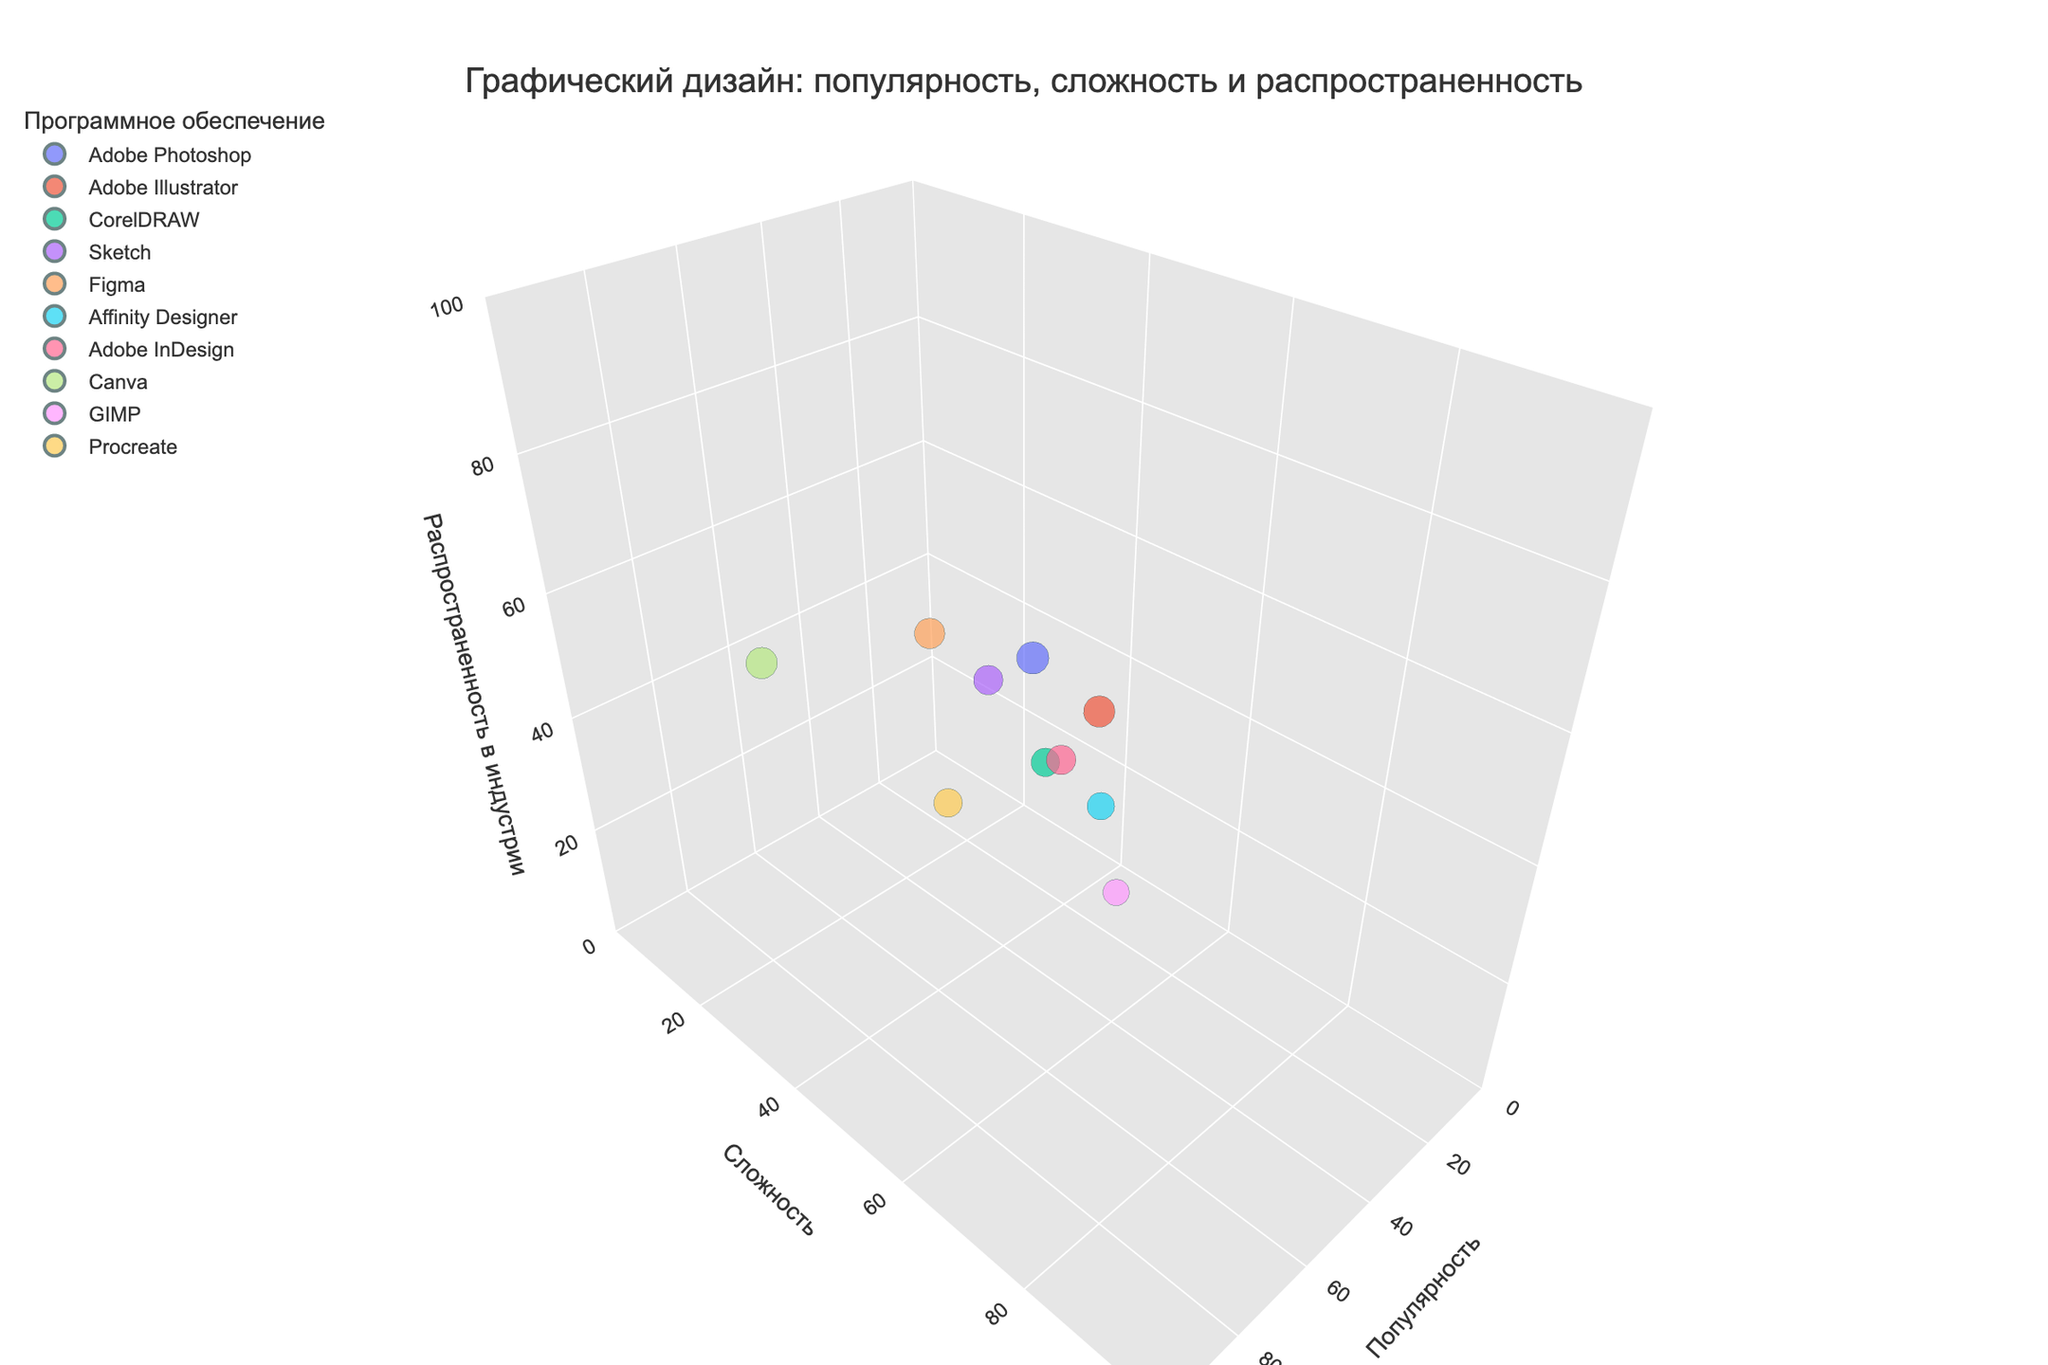How many software tools have a popularity higher than 80? By looking at the "Популярность" axis, identify the tools with a popularity value greater than 80. These are Adobe Photoshop, Adobe Illustrator, Canva, and Figma.
Answer: 4 Which software has the highest complexity and what is its value? Observe the "Сложность" axis and find the software with the maximal value. GIMP has the highest complexity with a value of 70.
Answer: GIMP, 70 Which software tools have an industry adoption rate equal to or higher than 70? Check the "Распространенность в индустрии" axis for values equal to or exceeding 70. Adobe Photoshop, Adobe Illustrator, Sketch, and Figma meet this criterion.
Answer: Adobe Photoshop, Adobe Illustrator, Sketch, Figma What is the combined popularity score of CorelDRAW, Sketch, and Procreate? Add the popularity scores of CorelDRAW (70), Sketch (75), and Procreate (70) together: 70 + 75 + 70.
Answer: 215 Is there any software that has both a complexity and industry adoption rate lower than 60? Examine the "Сложность" and "Распространенность в индустрии" axes. Procreate has a complexity of 50 and an industry adoption rate of 45, both below 60.
Answer: Yes, Procreate Compare Adobe InDesign and Affinity Designer in terms of industry adoption. Which one is higher and by how much? Look at their positions on the "Распространенность в индустрии" axis. Adobe InDesign has a rate of 65 and Affinity Designer has 55, so InDesign is higher by 10.
Answer: Adobe InDesign by 10 Which software tool has the largest bubble size, and what does it represent? The largest bubble-size corresponds to the highest popularity score. Adobe Photoshop, which has a popularity score of 90, has the largest bubble.
Answer: Adobe Photoshop, 90 What is the average complexity of Adobe Photoshop and Adobe Illustrator? Calculate the mean of the complexity scores: (75 from Adobe Photoshop + 80 from Adobe Illustrator) / 2.
Answer: 77.5 Identify the software with the lowest industry adoption rate. Inspect the "Распространенность в индустрии" axis for the minimal value. GIMP has the lowest industry adoption with a value of 40.
Answer: GIMP, 40 Does any software have a complexity higher than its popularity? If yes, which one? Compare complexity and popularity for all tools. Affinity Designer has a complexity (70) higher than its popularity (65).
Answer: Yes, Affinity Designer 